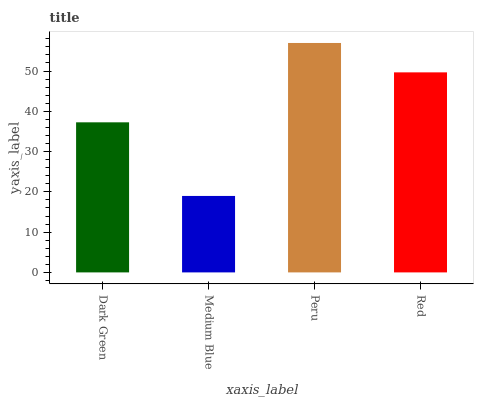Is Medium Blue the minimum?
Answer yes or no. Yes. Is Peru the maximum?
Answer yes or no. Yes. Is Peru the minimum?
Answer yes or no. No. Is Medium Blue the maximum?
Answer yes or no. No. Is Peru greater than Medium Blue?
Answer yes or no. Yes. Is Medium Blue less than Peru?
Answer yes or no. Yes. Is Medium Blue greater than Peru?
Answer yes or no. No. Is Peru less than Medium Blue?
Answer yes or no. No. Is Red the high median?
Answer yes or no. Yes. Is Dark Green the low median?
Answer yes or no. Yes. Is Dark Green the high median?
Answer yes or no. No. Is Peru the low median?
Answer yes or no. No. 